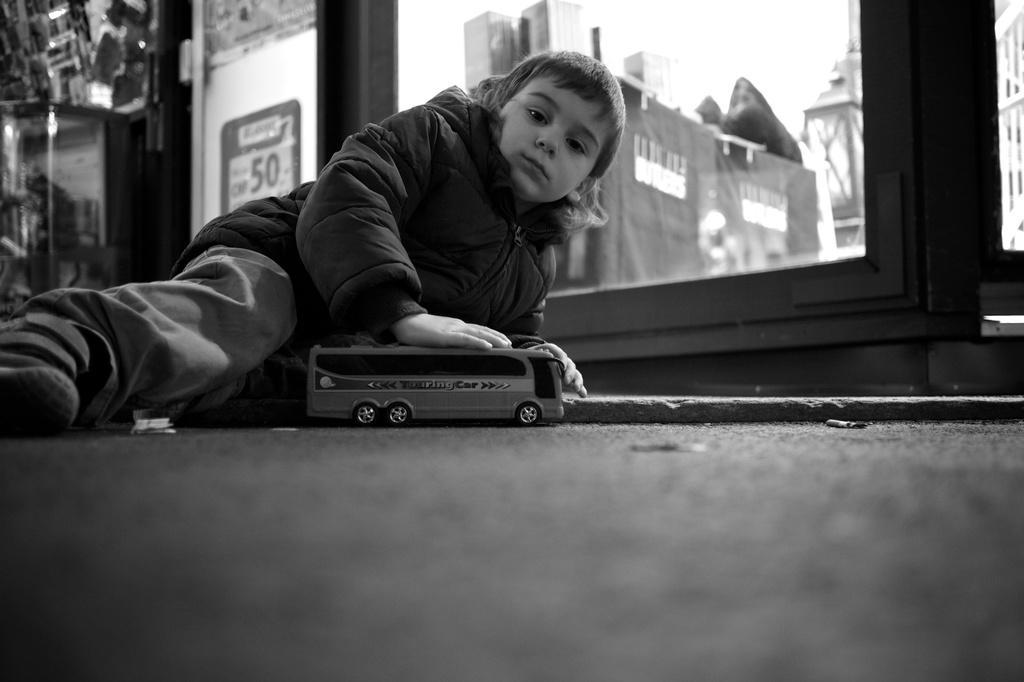Please provide a concise description of this image. In this image we can see a kid lying on the surface holding a toy. And we can see the glass window. The background is not clear. 